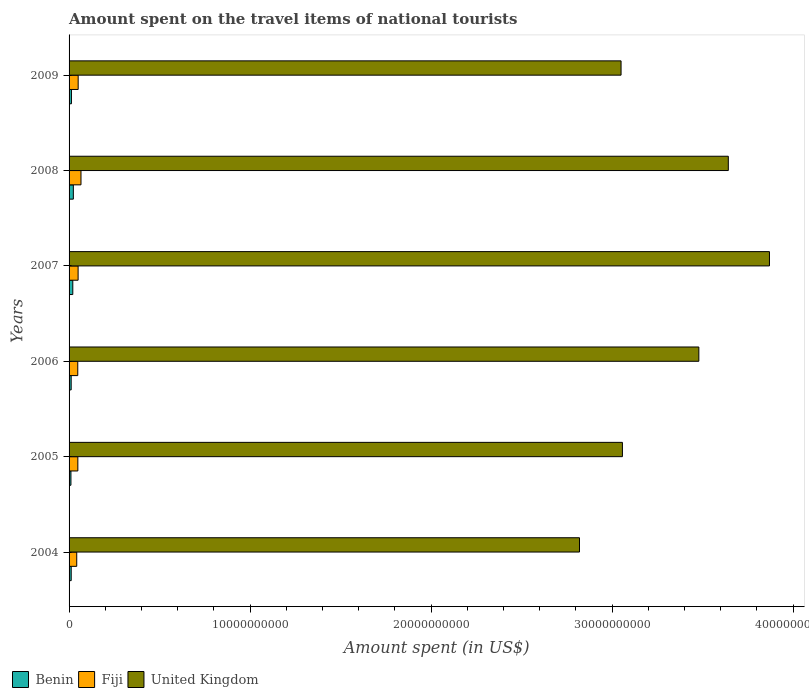How many different coloured bars are there?
Provide a short and direct response. 3. Are the number of bars on each tick of the Y-axis equal?
Provide a short and direct response. Yes. How many bars are there on the 4th tick from the top?
Ensure brevity in your answer.  3. How many bars are there on the 1st tick from the bottom?
Keep it short and to the point. 3. What is the label of the 1st group of bars from the top?
Offer a very short reply. 2009. What is the amount spent on the travel items of national tourists in Benin in 2005?
Ensure brevity in your answer.  1.03e+08. Across all years, what is the maximum amount spent on the travel items of national tourists in Fiji?
Ensure brevity in your answer.  6.58e+08. Across all years, what is the minimum amount spent on the travel items of national tourists in United Kingdom?
Provide a succinct answer. 2.82e+1. What is the total amount spent on the travel items of national tourists in United Kingdom in the graph?
Your response must be concise. 1.99e+11. What is the difference between the amount spent on the travel items of national tourists in United Kingdom in 2005 and that in 2007?
Offer a terse response. -8.12e+09. What is the difference between the amount spent on the travel items of national tourists in Benin in 2006 and the amount spent on the travel items of national tourists in United Kingdom in 2009?
Your response must be concise. -3.04e+1. What is the average amount spent on the travel items of national tourists in Benin per year?
Provide a succinct answer. 1.52e+08. In the year 2007, what is the difference between the amount spent on the travel items of national tourists in United Kingdom and amount spent on the travel items of national tourists in Benin?
Provide a short and direct response. 3.85e+1. In how many years, is the amount spent on the travel items of national tourists in United Kingdom greater than 34000000000 US$?
Your answer should be very brief. 3. What is the ratio of the amount spent on the travel items of national tourists in United Kingdom in 2005 to that in 2006?
Offer a terse response. 0.88. What is the difference between the highest and the second highest amount spent on the travel items of national tourists in Fiji?
Your response must be concise. 1.55e+08. What is the difference between the highest and the lowest amount spent on the travel items of national tourists in Benin?
Your answer should be very brief. 1.33e+08. What does the 2nd bar from the bottom in 2004 represents?
Provide a short and direct response. Fiji. Is it the case that in every year, the sum of the amount spent on the travel items of national tourists in Benin and amount spent on the travel items of national tourists in United Kingdom is greater than the amount spent on the travel items of national tourists in Fiji?
Give a very brief answer. Yes. How many bars are there?
Offer a terse response. 18. Are all the bars in the graph horizontal?
Your response must be concise. Yes. How many years are there in the graph?
Provide a succinct answer. 6. How many legend labels are there?
Provide a short and direct response. 3. What is the title of the graph?
Offer a very short reply. Amount spent on the travel items of national tourists. Does "Iraq" appear as one of the legend labels in the graph?
Your answer should be very brief. No. What is the label or title of the X-axis?
Your response must be concise. Amount spent (in US$). What is the label or title of the Y-axis?
Ensure brevity in your answer.  Years. What is the Amount spent (in US$) in Benin in 2004?
Make the answer very short. 1.18e+08. What is the Amount spent (in US$) of Fiji in 2004?
Your response must be concise. 4.23e+08. What is the Amount spent (in US$) in United Kingdom in 2004?
Keep it short and to the point. 2.82e+1. What is the Amount spent (in US$) of Benin in 2005?
Ensure brevity in your answer.  1.03e+08. What is the Amount spent (in US$) in Fiji in 2005?
Your response must be concise. 4.85e+08. What is the Amount spent (in US$) of United Kingdom in 2005?
Make the answer very short. 3.06e+1. What is the Amount spent (in US$) in Benin in 2006?
Your answer should be very brief. 1.16e+08. What is the Amount spent (in US$) in Fiji in 2006?
Make the answer very short. 4.80e+08. What is the Amount spent (in US$) of United Kingdom in 2006?
Ensure brevity in your answer.  3.48e+1. What is the Amount spent (in US$) of Benin in 2007?
Offer a very short reply. 2.06e+08. What is the Amount spent (in US$) of Fiji in 2007?
Ensure brevity in your answer.  4.99e+08. What is the Amount spent (in US$) of United Kingdom in 2007?
Keep it short and to the point. 3.87e+1. What is the Amount spent (in US$) of Benin in 2008?
Your answer should be compact. 2.36e+08. What is the Amount spent (in US$) in Fiji in 2008?
Provide a succinct answer. 6.58e+08. What is the Amount spent (in US$) in United Kingdom in 2008?
Provide a short and direct response. 3.64e+1. What is the Amount spent (in US$) in Benin in 2009?
Keep it short and to the point. 1.31e+08. What is the Amount spent (in US$) in Fiji in 2009?
Make the answer very short. 5.03e+08. What is the Amount spent (in US$) of United Kingdom in 2009?
Offer a very short reply. 3.05e+1. Across all years, what is the maximum Amount spent (in US$) of Benin?
Offer a terse response. 2.36e+08. Across all years, what is the maximum Amount spent (in US$) of Fiji?
Offer a terse response. 6.58e+08. Across all years, what is the maximum Amount spent (in US$) of United Kingdom?
Provide a short and direct response. 3.87e+1. Across all years, what is the minimum Amount spent (in US$) of Benin?
Offer a terse response. 1.03e+08. Across all years, what is the minimum Amount spent (in US$) in Fiji?
Offer a terse response. 4.23e+08. Across all years, what is the minimum Amount spent (in US$) in United Kingdom?
Keep it short and to the point. 2.82e+1. What is the total Amount spent (in US$) in Benin in the graph?
Offer a terse response. 9.10e+08. What is the total Amount spent (in US$) in Fiji in the graph?
Offer a very short reply. 3.05e+09. What is the total Amount spent (in US$) in United Kingdom in the graph?
Give a very brief answer. 1.99e+11. What is the difference between the Amount spent (in US$) of Benin in 2004 and that in 2005?
Provide a short and direct response. 1.50e+07. What is the difference between the Amount spent (in US$) of Fiji in 2004 and that in 2005?
Ensure brevity in your answer.  -6.20e+07. What is the difference between the Amount spent (in US$) of United Kingdom in 2004 and that in 2005?
Offer a terse response. -2.37e+09. What is the difference between the Amount spent (in US$) of Fiji in 2004 and that in 2006?
Provide a short and direct response. -5.70e+07. What is the difference between the Amount spent (in US$) in United Kingdom in 2004 and that in 2006?
Your answer should be very brief. -6.59e+09. What is the difference between the Amount spent (in US$) in Benin in 2004 and that in 2007?
Your answer should be very brief. -8.80e+07. What is the difference between the Amount spent (in US$) of Fiji in 2004 and that in 2007?
Provide a succinct answer. -7.60e+07. What is the difference between the Amount spent (in US$) of United Kingdom in 2004 and that in 2007?
Offer a terse response. -1.05e+1. What is the difference between the Amount spent (in US$) of Benin in 2004 and that in 2008?
Your response must be concise. -1.18e+08. What is the difference between the Amount spent (in US$) in Fiji in 2004 and that in 2008?
Your response must be concise. -2.35e+08. What is the difference between the Amount spent (in US$) of United Kingdom in 2004 and that in 2008?
Ensure brevity in your answer.  -8.22e+09. What is the difference between the Amount spent (in US$) in Benin in 2004 and that in 2009?
Provide a short and direct response. -1.30e+07. What is the difference between the Amount spent (in US$) of Fiji in 2004 and that in 2009?
Your answer should be very brief. -8.00e+07. What is the difference between the Amount spent (in US$) in United Kingdom in 2004 and that in 2009?
Keep it short and to the point. -2.30e+09. What is the difference between the Amount spent (in US$) of Benin in 2005 and that in 2006?
Provide a succinct answer. -1.30e+07. What is the difference between the Amount spent (in US$) in Fiji in 2005 and that in 2006?
Offer a terse response. 5.00e+06. What is the difference between the Amount spent (in US$) in United Kingdom in 2005 and that in 2006?
Provide a succinct answer. -4.22e+09. What is the difference between the Amount spent (in US$) in Benin in 2005 and that in 2007?
Your response must be concise. -1.03e+08. What is the difference between the Amount spent (in US$) of Fiji in 2005 and that in 2007?
Provide a succinct answer. -1.40e+07. What is the difference between the Amount spent (in US$) in United Kingdom in 2005 and that in 2007?
Ensure brevity in your answer.  -8.12e+09. What is the difference between the Amount spent (in US$) of Benin in 2005 and that in 2008?
Keep it short and to the point. -1.33e+08. What is the difference between the Amount spent (in US$) of Fiji in 2005 and that in 2008?
Keep it short and to the point. -1.73e+08. What is the difference between the Amount spent (in US$) in United Kingdom in 2005 and that in 2008?
Provide a succinct answer. -5.85e+09. What is the difference between the Amount spent (in US$) of Benin in 2005 and that in 2009?
Ensure brevity in your answer.  -2.80e+07. What is the difference between the Amount spent (in US$) of Fiji in 2005 and that in 2009?
Offer a very short reply. -1.80e+07. What is the difference between the Amount spent (in US$) in United Kingdom in 2005 and that in 2009?
Offer a terse response. 7.50e+07. What is the difference between the Amount spent (in US$) of Benin in 2006 and that in 2007?
Your answer should be very brief. -9.00e+07. What is the difference between the Amount spent (in US$) of Fiji in 2006 and that in 2007?
Your answer should be compact. -1.90e+07. What is the difference between the Amount spent (in US$) of United Kingdom in 2006 and that in 2007?
Provide a short and direct response. -3.90e+09. What is the difference between the Amount spent (in US$) of Benin in 2006 and that in 2008?
Your answer should be compact. -1.20e+08. What is the difference between the Amount spent (in US$) of Fiji in 2006 and that in 2008?
Your response must be concise. -1.78e+08. What is the difference between the Amount spent (in US$) of United Kingdom in 2006 and that in 2008?
Offer a very short reply. -1.63e+09. What is the difference between the Amount spent (in US$) in Benin in 2006 and that in 2009?
Make the answer very short. -1.50e+07. What is the difference between the Amount spent (in US$) of Fiji in 2006 and that in 2009?
Provide a short and direct response. -2.30e+07. What is the difference between the Amount spent (in US$) in United Kingdom in 2006 and that in 2009?
Make the answer very short. 4.30e+09. What is the difference between the Amount spent (in US$) of Benin in 2007 and that in 2008?
Your answer should be very brief. -3.00e+07. What is the difference between the Amount spent (in US$) of Fiji in 2007 and that in 2008?
Keep it short and to the point. -1.59e+08. What is the difference between the Amount spent (in US$) in United Kingdom in 2007 and that in 2008?
Keep it short and to the point. 2.27e+09. What is the difference between the Amount spent (in US$) of Benin in 2007 and that in 2009?
Provide a short and direct response. 7.50e+07. What is the difference between the Amount spent (in US$) of United Kingdom in 2007 and that in 2009?
Ensure brevity in your answer.  8.20e+09. What is the difference between the Amount spent (in US$) of Benin in 2008 and that in 2009?
Your answer should be very brief. 1.05e+08. What is the difference between the Amount spent (in US$) in Fiji in 2008 and that in 2009?
Provide a succinct answer. 1.55e+08. What is the difference between the Amount spent (in US$) in United Kingdom in 2008 and that in 2009?
Your response must be concise. 5.93e+09. What is the difference between the Amount spent (in US$) of Benin in 2004 and the Amount spent (in US$) of Fiji in 2005?
Offer a terse response. -3.67e+08. What is the difference between the Amount spent (in US$) of Benin in 2004 and the Amount spent (in US$) of United Kingdom in 2005?
Give a very brief answer. -3.05e+1. What is the difference between the Amount spent (in US$) of Fiji in 2004 and the Amount spent (in US$) of United Kingdom in 2005?
Your answer should be very brief. -3.02e+1. What is the difference between the Amount spent (in US$) of Benin in 2004 and the Amount spent (in US$) of Fiji in 2006?
Your answer should be compact. -3.62e+08. What is the difference between the Amount spent (in US$) of Benin in 2004 and the Amount spent (in US$) of United Kingdom in 2006?
Ensure brevity in your answer.  -3.47e+1. What is the difference between the Amount spent (in US$) of Fiji in 2004 and the Amount spent (in US$) of United Kingdom in 2006?
Offer a terse response. -3.44e+1. What is the difference between the Amount spent (in US$) in Benin in 2004 and the Amount spent (in US$) in Fiji in 2007?
Offer a very short reply. -3.81e+08. What is the difference between the Amount spent (in US$) of Benin in 2004 and the Amount spent (in US$) of United Kingdom in 2007?
Provide a succinct answer. -3.86e+1. What is the difference between the Amount spent (in US$) of Fiji in 2004 and the Amount spent (in US$) of United Kingdom in 2007?
Give a very brief answer. -3.83e+1. What is the difference between the Amount spent (in US$) in Benin in 2004 and the Amount spent (in US$) in Fiji in 2008?
Give a very brief answer. -5.40e+08. What is the difference between the Amount spent (in US$) in Benin in 2004 and the Amount spent (in US$) in United Kingdom in 2008?
Ensure brevity in your answer.  -3.63e+1. What is the difference between the Amount spent (in US$) of Fiji in 2004 and the Amount spent (in US$) of United Kingdom in 2008?
Provide a succinct answer. -3.60e+1. What is the difference between the Amount spent (in US$) in Benin in 2004 and the Amount spent (in US$) in Fiji in 2009?
Give a very brief answer. -3.85e+08. What is the difference between the Amount spent (in US$) of Benin in 2004 and the Amount spent (in US$) of United Kingdom in 2009?
Your response must be concise. -3.04e+1. What is the difference between the Amount spent (in US$) of Fiji in 2004 and the Amount spent (in US$) of United Kingdom in 2009?
Make the answer very short. -3.01e+1. What is the difference between the Amount spent (in US$) of Benin in 2005 and the Amount spent (in US$) of Fiji in 2006?
Give a very brief answer. -3.77e+08. What is the difference between the Amount spent (in US$) in Benin in 2005 and the Amount spent (in US$) in United Kingdom in 2006?
Give a very brief answer. -3.47e+1. What is the difference between the Amount spent (in US$) of Fiji in 2005 and the Amount spent (in US$) of United Kingdom in 2006?
Keep it short and to the point. -3.43e+1. What is the difference between the Amount spent (in US$) of Benin in 2005 and the Amount spent (in US$) of Fiji in 2007?
Your response must be concise. -3.96e+08. What is the difference between the Amount spent (in US$) in Benin in 2005 and the Amount spent (in US$) in United Kingdom in 2007?
Provide a short and direct response. -3.86e+1. What is the difference between the Amount spent (in US$) of Fiji in 2005 and the Amount spent (in US$) of United Kingdom in 2007?
Your answer should be compact. -3.82e+1. What is the difference between the Amount spent (in US$) of Benin in 2005 and the Amount spent (in US$) of Fiji in 2008?
Provide a short and direct response. -5.55e+08. What is the difference between the Amount spent (in US$) of Benin in 2005 and the Amount spent (in US$) of United Kingdom in 2008?
Your answer should be very brief. -3.63e+1. What is the difference between the Amount spent (in US$) in Fiji in 2005 and the Amount spent (in US$) in United Kingdom in 2008?
Your response must be concise. -3.59e+1. What is the difference between the Amount spent (in US$) in Benin in 2005 and the Amount spent (in US$) in Fiji in 2009?
Ensure brevity in your answer.  -4.00e+08. What is the difference between the Amount spent (in US$) in Benin in 2005 and the Amount spent (in US$) in United Kingdom in 2009?
Keep it short and to the point. -3.04e+1. What is the difference between the Amount spent (in US$) of Fiji in 2005 and the Amount spent (in US$) of United Kingdom in 2009?
Keep it short and to the point. -3.00e+1. What is the difference between the Amount spent (in US$) in Benin in 2006 and the Amount spent (in US$) in Fiji in 2007?
Offer a terse response. -3.83e+08. What is the difference between the Amount spent (in US$) in Benin in 2006 and the Amount spent (in US$) in United Kingdom in 2007?
Give a very brief answer. -3.86e+1. What is the difference between the Amount spent (in US$) of Fiji in 2006 and the Amount spent (in US$) of United Kingdom in 2007?
Offer a terse response. -3.82e+1. What is the difference between the Amount spent (in US$) of Benin in 2006 and the Amount spent (in US$) of Fiji in 2008?
Your response must be concise. -5.42e+08. What is the difference between the Amount spent (in US$) in Benin in 2006 and the Amount spent (in US$) in United Kingdom in 2008?
Offer a very short reply. -3.63e+1. What is the difference between the Amount spent (in US$) in Fiji in 2006 and the Amount spent (in US$) in United Kingdom in 2008?
Your response must be concise. -3.59e+1. What is the difference between the Amount spent (in US$) in Benin in 2006 and the Amount spent (in US$) in Fiji in 2009?
Your response must be concise. -3.87e+08. What is the difference between the Amount spent (in US$) in Benin in 2006 and the Amount spent (in US$) in United Kingdom in 2009?
Your response must be concise. -3.04e+1. What is the difference between the Amount spent (in US$) of Fiji in 2006 and the Amount spent (in US$) of United Kingdom in 2009?
Your answer should be compact. -3.00e+1. What is the difference between the Amount spent (in US$) in Benin in 2007 and the Amount spent (in US$) in Fiji in 2008?
Your answer should be compact. -4.52e+08. What is the difference between the Amount spent (in US$) of Benin in 2007 and the Amount spent (in US$) of United Kingdom in 2008?
Make the answer very short. -3.62e+1. What is the difference between the Amount spent (in US$) of Fiji in 2007 and the Amount spent (in US$) of United Kingdom in 2008?
Your answer should be very brief. -3.59e+1. What is the difference between the Amount spent (in US$) of Benin in 2007 and the Amount spent (in US$) of Fiji in 2009?
Your answer should be compact. -2.97e+08. What is the difference between the Amount spent (in US$) of Benin in 2007 and the Amount spent (in US$) of United Kingdom in 2009?
Give a very brief answer. -3.03e+1. What is the difference between the Amount spent (in US$) in Fiji in 2007 and the Amount spent (in US$) in United Kingdom in 2009?
Your answer should be very brief. -3.00e+1. What is the difference between the Amount spent (in US$) in Benin in 2008 and the Amount spent (in US$) in Fiji in 2009?
Offer a terse response. -2.67e+08. What is the difference between the Amount spent (in US$) of Benin in 2008 and the Amount spent (in US$) of United Kingdom in 2009?
Your answer should be compact. -3.03e+1. What is the difference between the Amount spent (in US$) in Fiji in 2008 and the Amount spent (in US$) in United Kingdom in 2009?
Offer a terse response. -2.98e+1. What is the average Amount spent (in US$) in Benin per year?
Your answer should be very brief. 1.52e+08. What is the average Amount spent (in US$) of Fiji per year?
Make the answer very short. 5.08e+08. What is the average Amount spent (in US$) of United Kingdom per year?
Your answer should be compact. 3.32e+1. In the year 2004, what is the difference between the Amount spent (in US$) of Benin and Amount spent (in US$) of Fiji?
Keep it short and to the point. -3.05e+08. In the year 2004, what is the difference between the Amount spent (in US$) of Benin and Amount spent (in US$) of United Kingdom?
Your answer should be compact. -2.81e+1. In the year 2004, what is the difference between the Amount spent (in US$) in Fiji and Amount spent (in US$) in United Kingdom?
Ensure brevity in your answer.  -2.78e+1. In the year 2005, what is the difference between the Amount spent (in US$) of Benin and Amount spent (in US$) of Fiji?
Your answer should be very brief. -3.82e+08. In the year 2005, what is the difference between the Amount spent (in US$) in Benin and Amount spent (in US$) in United Kingdom?
Provide a succinct answer. -3.05e+1. In the year 2005, what is the difference between the Amount spent (in US$) of Fiji and Amount spent (in US$) of United Kingdom?
Keep it short and to the point. -3.01e+1. In the year 2006, what is the difference between the Amount spent (in US$) in Benin and Amount spent (in US$) in Fiji?
Give a very brief answer. -3.64e+08. In the year 2006, what is the difference between the Amount spent (in US$) in Benin and Amount spent (in US$) in United Kingdom?
Your answer should be very brief. -3.47e+1. In the year 2006, what is the difference between the Amount spent (in US$) of Fiji and Amount spent (in US$) of United Kingdom?
Keep it short and to the point. -3.43e+1. In the year 2007, what is the difference between the Amount spent (in US$) in Benin and Amount spent (in US$) in Fiji?
Offer a very short reply. -2.93e+08. In the year 2007, what is the difference between the Amount spent (in US$) in Benin and Amount spent (in US$) in United Kingdom?
Offer a terse response. -3.85e+1. In the year 2007, what is the difference between the Amount spent (in US$) of Fiji and Amount spent (in US$) of United Kingdom?
Keep it short and to the point. -3.82e+1. In the year 2008, what is the difference between the Amount spent (in US$) of Benin and Amount spent (in US$) of Fiji?
Provide a succinct answer. -4.22e+08. In the year 2008, what is the difference between the Amount spent (in US$) of Benin and Amount spent (in US$) of United Kingdom?
Make the answer very short. -3.62e+1. In the year 2008, what is the difference between the Amount spent (in US$) of Fiji and Amount spent (in US$) of United Kingdom?
Offer a very short reply. -3.58e+1. In the year 2009, what is the difference between the Amount spent (in US$) of Benin and Amount spent (in US$) of Fiji?
Provide a short and direct response. -3.72e+08. In the year 2009, what is the difference between the Amount spent (in US$) in Benin and Amount spent (in US$) in United Kingdom?
Offer a very short reply. -3.04e+1. In the year 2009, what is the difference between the Amount spent (in US$) in Fiji and Amount spent (in US$) in United Kingdom?
Provide a short and direct response. -3.00e+1. What is the ratio of the Amount spent (in US$) in Benin in 2004 to that in 2005?
Provide a short and direct response. 1.15. What is the ratio of the Amount spent (in US$) of Fiji in 2004 to that in 2005?
Your answer should be compact. 0.87. What is the ratio of the Amount spent (in US$) in United Kingdom in 2004 to that in 2005?
Offer a terse response. 0.92. What is the ratio of the Amount spent (in US$) in Benin in 2004 to that in 2006?
Provide a short and direct response. 1.02. What is the ratio of the Amount spent (in US$) in Fiji in 2004 to that in 2006?
Offer a very short reply. 0.88. What is the ratio of the Amount spent (in US$) in United Kingdom in 2004 to that in 2006?
Provide a short and direct response. 0.81. What is the ratio of the Amount spent (in US$) of Benin in 2004 to that in 2007?
Keep it short and to the point. 0.57. What is the ratio of the Amount spent (in US$) of Fiji in 2004 to that in 2007?
Give a very brief answer. 0.85. What is the ratio of the Amount spent (in US$) in United Kingdom in 2004 to that in 2007?
Keep it short and to the point. 0.73. What is the ratio of the Amount spent (in US$) in Fiji in 2004 to that in 2008?
Offer a terse response. 0.64. What is the ratio of the Amount spent (in US$) of United Kingdom in 2004 to that in 2008?
Your answer should be very brief. 0.77. What is the ratio of the Amount spent (in US$) of Benin in 2004 to that in 2009?
Your answer should be compact. 0.9. What is the ratio of the Amount spent (in US$) in Fiji in 2004 to that in 2009?
Make the answer very short. 0.84. What is the ratio of the Amount spent (in US$) of United Kingdom in 2004 to that in 2009?
Make the answer very short. 0.92. What is the ratio of the Amount spent (in US$) in Benin in 2005 to that in 2006?
Your answer should be very brief. 0.89. What is the ratio of the Amount spent (in US$) in Fiji in 2005 to that in 2006?
Give a very brief answer. 1.01. What is the ratio of the Amount spent (in US$) of United Kingdom in 2005 to that in 2006?
Offer a terse response. 0.88. What is the ratio of the Amount spent (in US$) in Benin in 2005 to that in 2007?
Your answer should be very brief. 0.5. What is the ratio of the Amount spent (in US$) in Fiji in 2005 to that in 2007?
Your answer should be very brief. 0.97. What is the ratio of the Amount spent (in US$) in United Kingdom in 2005 to that in 2007?
Your response must be concise. 0.79. What is the ratio of the Amount spent (in US$) of Benin in 2005 to that in 2008?
Give a very brief answer. 0.44. What is the ratio of the Amount spent (in US$) in Fiji in 2005 to that in 2008?
Keep it short and to the point. 0.74. What is the ratio of the Amount spent (in US$) in United Kingdom in 2005 to that in 2008?
Make the answer very short. 0.84. What is the ratio of the Amount spent (in US$) of Benin in 2005 to that in 2009?
Your response must be concise. 0.79. What is the ratio of the Amount spent (in US$) of Fiji in 2005 to that in 2009?
Give a very brief answer. 0.96. What is the ratio of the Amount spent (in US$) in Benin in 2006 to that in 2007?
Keep it short and to the point. 0.56. What is the ratio of the Amount spent (in US$) of Fiji in 2006 to that in 2007?
Offer a very short reply. 0.96. What is the ratio of the Amount spent (in US$) in United Kingdom in 2006 to that in 2007?
Ensure brevity in your answer.  0.9. What is the ratio of the Amount spent (in US$) in Benin in 2006 to that in 2008?
Your answer should be very brief. 0.49. What is the ratio of the Amount spent (in US$) in Fiji in 2006 to that in 2008?
Keep it short and to the point. 0.73. What is the ratio of the Amount spent (in US$) of United Kingdom in 2006 to that in 2008?
Ensure brevity in your answer.  0.96. What is the ratio of the Amount spent (in US$) in Benin in 2006 to that in 2009?
Offer a very short reply. 0.89. What is the ratio of the Amount spent (in US$) in Fiji in 2006 to that in 2009?
Ensure brevity in your answer.  0.95. What is the ratio of the Amount spent (in US$) of United Kingdom in 2006 to that in 2009?
Your answer should be very brief. 1.14. What is the ratio of the Amount spent (in US$) in Benin in 2007 to that in 2008?
Offer a very short reply. 0.87. What is the ratio of the Amount spent (in US$) in Fiji in 2007 to that in 2008?
Make the answer very short. 0.76. What is the ratio of the Amount spent (in US$) in United Kingdom in 2007 to that in 2008?
Keep it short and to the point. 1.06. What is the ratio of the Amount spent (in US$) of Benin in 2007 to that in 2009?
Ensure brevity in your answer.  1.57. What is the ratio of the Amount spent (in US$) in Fiji in 2007 to that in 2009?
Make the answer very short. 0.99. What is the ratio of the Amount spent (in US$) of United Kingdom in 2007 to that in 2009?
Provide a short and direct response. 1.27. What is the ratio of the Amount spent (in US$) in Benin in 2008 to that in 2009?
Your response must be concise. 1.8. What is the ratio of the Amount spent (in US$) of Fiji in 2008 to that in 2009?
Make the answer very short. 1.31. What is the ratio of the Amount spent (in US$) in United Kingdom in 2008 to that in 2009?
Make the answer very short. 1.19. What is the difference between the highest and the second highest Amount spent (in US$) of Benin?
Your response must be concise. 3.00e+07. What is the difference between the highest and the second highest Amount spent (in US$) in Fiji?
Offer a very short reply. 1.55e+08. What is the difference between the highest and the second highest Amount spent (in US$) in United Kingdom?
Provide a succinct answer. 2.27e+09. What is the difference between the highest and the lowest Amount spent (in US$) in Benin?
Ensure brevity in your answer.  1.33e+08. What is the difference between the highest and the lowest Amount spent (in US$) of Fiji?
Provide a short and direct response. 2.35e+08. What is the difference between the highest and the lowest Amount spent (in US$) of United Kingdom?
Make the answer very short. 1.05e+1. 